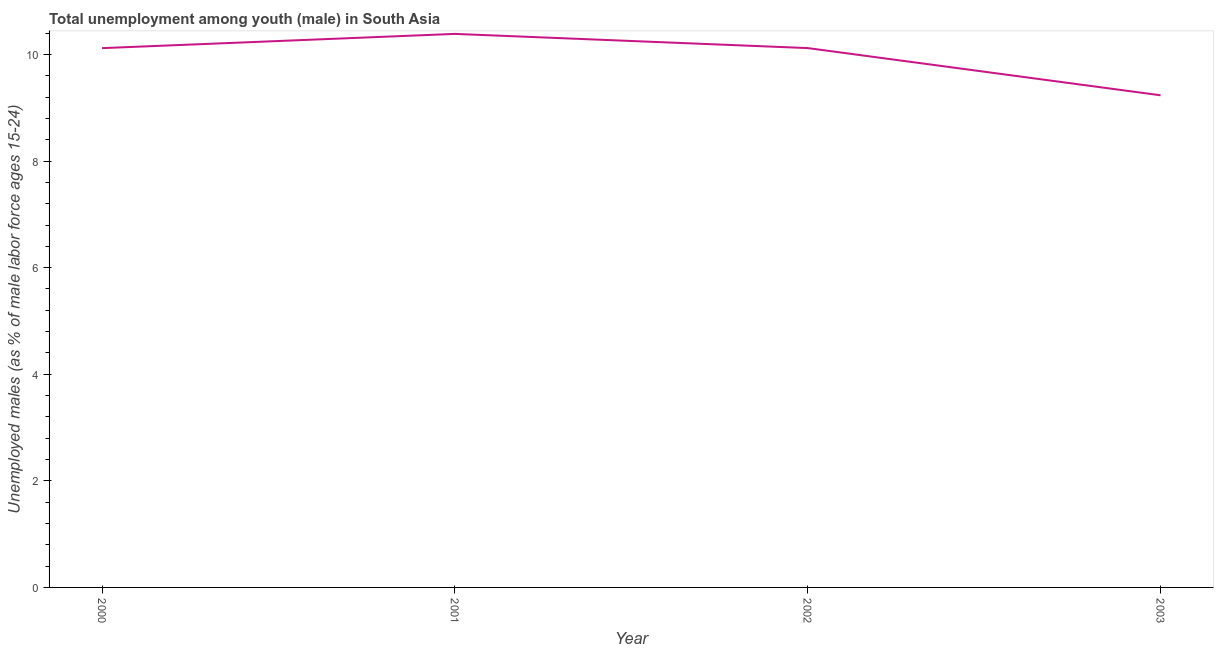What is the unemployed male youth population in 2002?
Offer a terse response. 10.12. Across all years, what is the maximum unemployed male youth population?
Give a very brief answer. 10.39. Across all years, what is the minimum unemployed male youth population?
Provide a short and direct response. 9.23. What is the sum of the unemployed male youth population?
Provide a succinct answer. 39.86. What is the difference between the unemployed male youth population in 2000 and 2003?
Keep it short and to the point. 0.88. What is the average unemployed male youth population per year?
Provide a succinct answer. 9.96. What is the median unemployed male youth population?
Your answer should be very brief. 10.12. What is the ratio of the unemployed male youth population in 2001 to that in 2002?
Your answer should be compact. 1.03. Is the unemployed male youth population in 2002 less than that in 2003?
Keep it short and to the point. No. Is the difference between the unemployed male youth population in 2000 and 2002 greater than the difference between any two years?
Your answer should be very brief. No. What is the difference between the highest and the second highest unemployed male youth population?
Your response must be concise. 0.27. What is the difference between the highest and the lowest unemployed male youth population?
Provide a short and direct response. 1.15. In how many years, is the unemployed male youth population greater than the average unemployed male youth population taken over all years?
Provide a succinct answer. 3. How many lines are there?
Ensure brevity in your answer.  1. Are the values on the major ticks of Y-axis written in scientific E-notation?
Offer a very short reply. No. Does the graph contain any zero values?
Keep it short and to the point. No. What is the title of the graph?
Make the answer very short. Total unemployment among youth (male) in South Asia. What is the label or title of the X-axis?
Provide a succinct answer. Year. What is the label or title of the Y-axis?
Offer a very short reply. Unemployed males (as % of male labor force ages 15-24). What is the Unemployed males (as % of male labor force ages 15-24) of 2000?
Offer a terse response. 10.12. What is the Unemployed males (as % of male labor force ages 15-24) in 2001?
Ensure brevity in your answer.  10.39. What is the Unemployed males (as % of male labor force ages 15-24) of 2002?
Ensure brevity in your answer.  10.12. What is the Unemployed males (as % of male labor force ages 15-24) in 2003?
Your answer should be compact. 9.23. What is the difference between the Unemployed males (as % of male labor force ages 15-24) in 2000 and 2001?
Keep it short and to the point. -0.27. What is the difference between the Unemployed males (as % of male labor force ages 15-24) in 2000 and 2002?
Your answer should be very brief. -0. What is the difference between the Unemployed males (as % of male labor force ages 15-24) in 2000 and 2003?
Your response must be concise. 0.88. What is the difference between the Unemployed males (as % of male labor force ages 15-24) in 2001 and 2002?
Your response must be concise. 0.27. What is the difference between the Unemployed males (as % of male labor force ages 15-24) in 2001 and 2003?
Provide a short and direct response. 1.15. What is the difference between the Unemployed males (as % of male labor force ages 15-24) in 2002 and 2003?
Your answer should be very brief. 0.89. What is the ratio of the Unemployed males (as % of male labor force ages 15-24) in 2000 to that in 2001?
Keep it short and to the point. 0.97. What is the ratio of the Unemployed males (as % of male labor force ages 15-24) in 2000 to that in 2003?
Give a very brief answer. 1.1. What is the ratio of the Unemployed males (as % of male labor force ages 15-24) in 2001 to that in 2003?
Keep it short and to the point. 1.12. What is the ratio of the Unemployed males (as % of male labor force ages 15-24) in 2002 to that in 2003?
Keep it short and to the point. 1.1. 